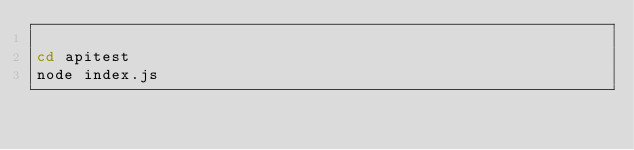<code> <loc_0><loc_0><loc_500><loc_500><_Bash_>
cd apitest
node index.js
</code> 